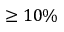Convert formula to latex. <formula><loc_0><loc_0><loc_500><loc_500>\geq 1 0 \%</formula> 